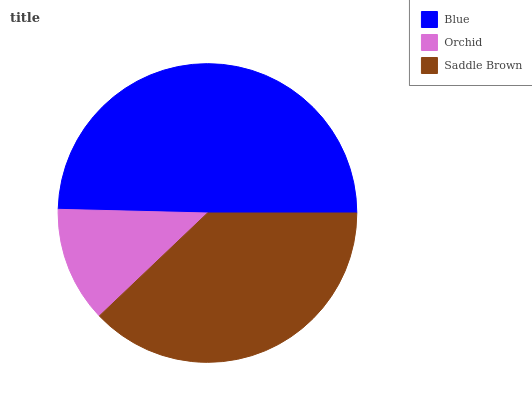Is Orchid the minimum?
Answer yes or no. Yes. Is Blue the maximum?
Answer yes or no. Yes. Is Saddle Brown the minimum?
Answer yes or no. No. Is Saddle Brown the maximum?
Answer yes or no. No. Is Saddle Brown greater than Orchid?
Answer yes or no. Yes. Is Orchid less than Saddle Brown?
Answer yes or no. Yes. Is Orchid greater than Saddle Brown?
Answer yes or no. No. Is Saddle Brown less than Orchid?
Answer yes or no. No. Is Saddle Brown the high median?
Answer yes or no. Yes. Is Saddle Brown the low median?
Answer yes or no. Yes. Is Orchid the high median?
Answer yes or no. No. Is Orchid the low median?
Answer yes or no. No. 